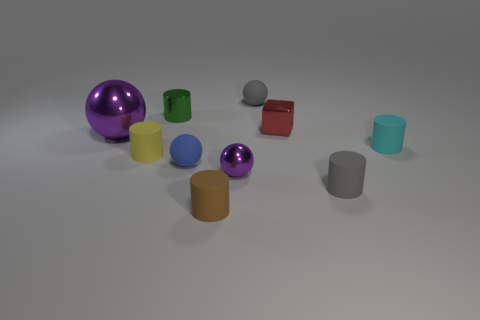Does the tiny blue sphere have the same material as the gray object that is right of the small gray ball?
Offer a very short reply. Yes. What number of other things are there of the same shape as the green metal object?
Keep it short and to the point. 4. There is a metal cube; is it the same color as the tiny metal object to the left of the small purple thing?
Give a very brief answer. No. What is the shape of the tiny gray object behind the tiny yellow matte cylinder that is to the left of the gray rubber sphere?
Give a very brief answer. Sphere. What size is the other ball that is the same color as the large metal ball?
Offer a very short reply. Small. There is a tiny gray rubber thing that is behind the small green shiny cylinder; does it have the same shape as the small purple shiny thing?
Your answer should be very brief. Yes. Are there more large purple metallic things that are behind the large purple thing than small blue spheres on the left side of the blue matte sphere?
Keep it short and to the point. No. How many things are in front of the matte cylinder that is to the right of the gray cylinder?
Provide a short and direct response. 5. There is a tiny sphere that is the same color as the large metallic ball; what material is it?
Keep it short and to the point. Metal. What number of other objects are the same color as the metallic cube?
Your answer should be compact. 0. 